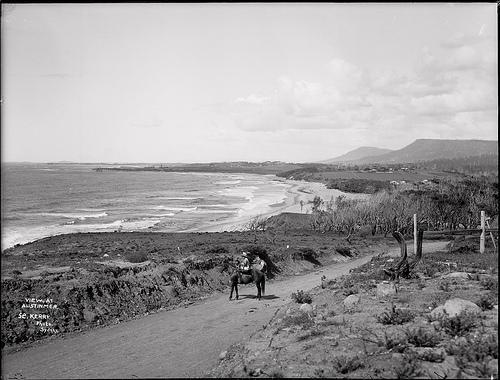How many animals are in the picture?
Give a very brief answer. 1. How many people are there?
Give a very brief answer. 2. How many animals are there?
Give a very brief answer. 1. 